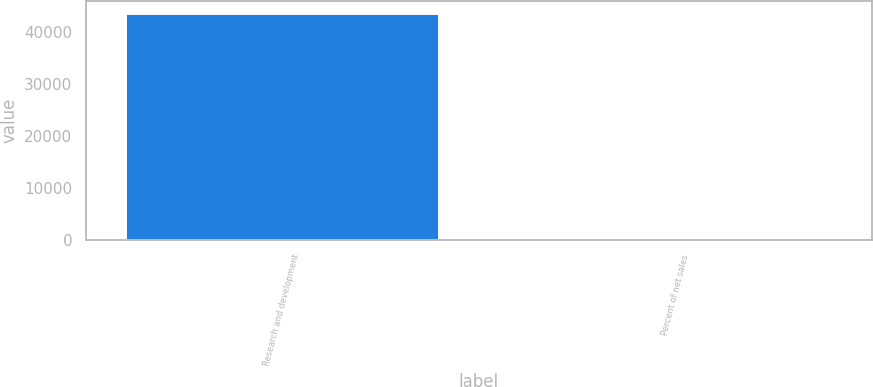<chart> <loc_0><loc_0><loc_500><loc_500><bar_chart><fcel>Research and development<fcel>Percent of net sales<nl><fcel>43706<fcel>7.6<nl></chart> 